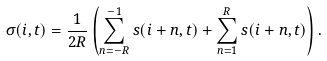Convert formula to latex. <formula><loc_0><loc_0><loc_500><loc_500>\sigma ( i , t ) = \frac { 1 } { 2 R } \left ( \sum _ { n = - R } ^ { - 1 } s ( i + n , t ) + \sum _ { n = 1 } ^ { R } s ( i + n , t ) \right ) .</formula> 